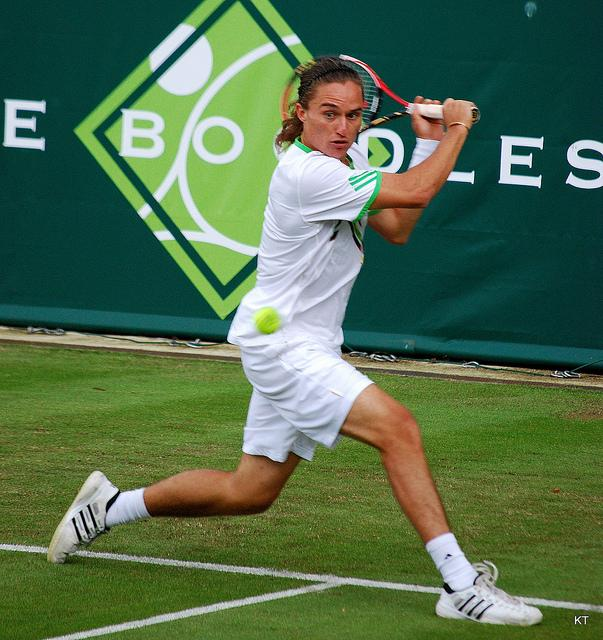What is the color of tennis ball used in earlier days? Please explain your reasoning. yellow. The tennis ball is yellowish green. 